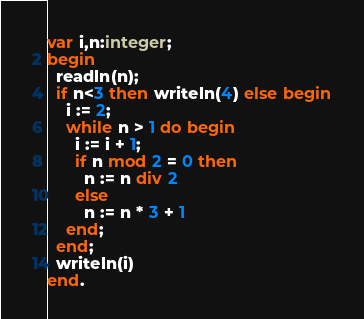Convert code to text. <code><loc_0><loc_0><loc_500><loc_500><_Pascal_>var i,n:integer;
begin
  readln(n);
  if n<3 then writeln(4) else begin
    i := 2;
    while n > 1 do begin
      i := i + 1;
      if n mod 2 = 0 then
        n := n div 2
      else
        n := n * 3 + 1
    end;
  end;
  writeln(i)
end.</code> 